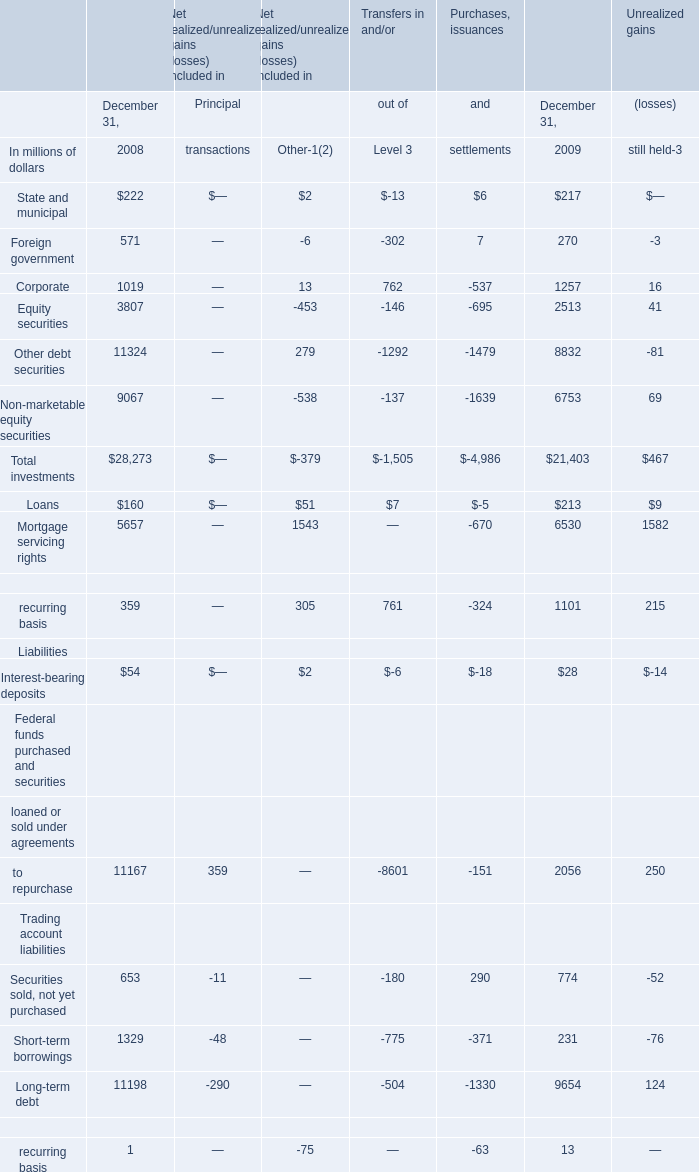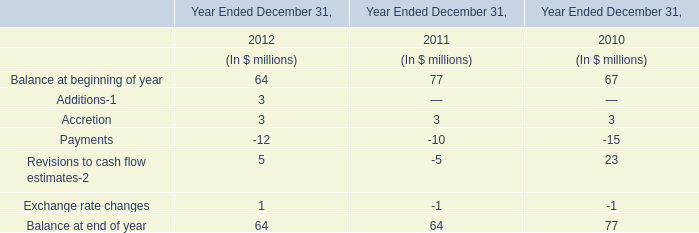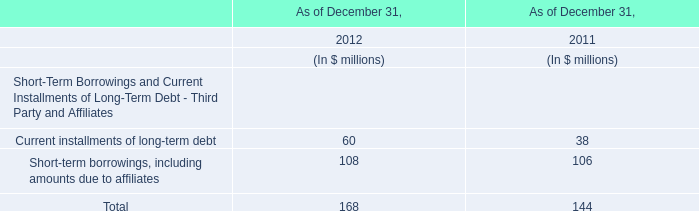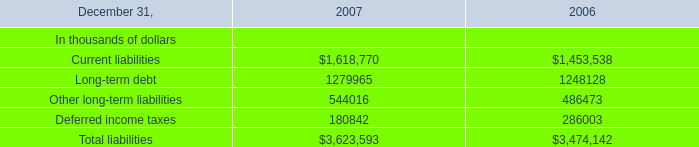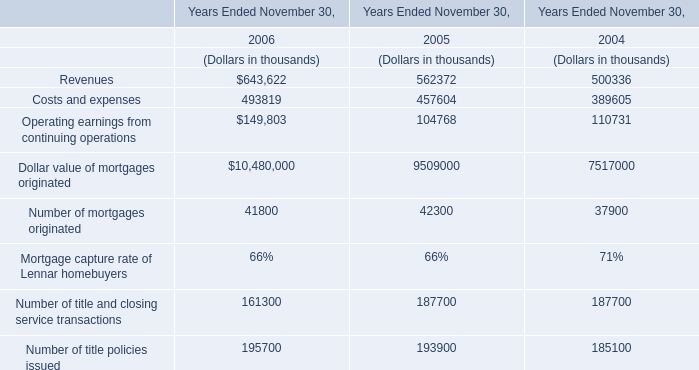What's the current increasing rate of Securities sold, not yet purchased? 
Computations: ((774 - 653) / 653)
Answer: 0.1853. 